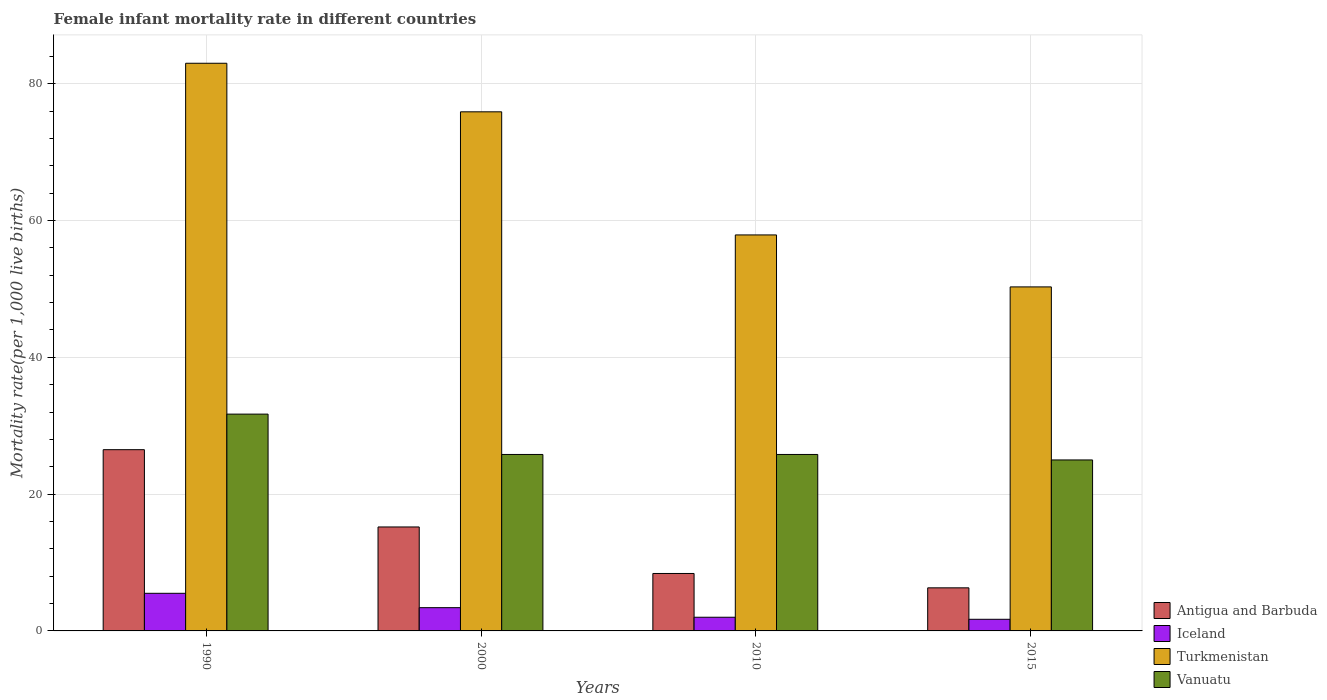Are the number of bars per tick equal to the number of legend labels?
Provide a succinct answer. Yes. How many bars are there on the 3rd tick from the right?
Keep it short and to the point. 4. In how many cases, is the number of bars for a given year not equal to the number of legend labels?
Provide a short and direct response. 0. What is the female infant mortality rate in Vanuatu in 2015?
Make the answer very short. 25. Across all years, what is the maximum female infant mortality rate in Antigua and Barbuda?
Your answer should be compact. 26.5. Across all years, what is the minimum female infant mortality rate in Antigua and Barbuda?
Your answer should be compact. 6.3. In which year was the female infant mortality rate in Iceland minimum?
Keep it short and to the point. 2015. What is the total female infant mortality rate in Antigua and Barbuda in the graph?
Your answer should be compact. 56.4. What is the difference between the female infant mortality rate in Turkmenistan in 1990 and that in 2000?
Offer a terse response. 7.1. What is the difference between the female infant mortality rate in Vanuatu in 2010 and the female infant mortality rate in Turkmenistan in 1990?
Keep it short and to the point. -57.2. What is the average female infant mortality rate in Turkmenistan per year?
Your response must be concise. 66.78. In the year 2010, what is the difference between the female infant mortality rate in Turkmenistan and female infant mortality rate in Antigua and Barbuda?
Your response must be concise. 49.5. In how many years, is the female infant mortality rate in Antigua and Barbuda greater than 40?
Ensure brevity in your answer.  0. What is the ratio of the female infant mortality rate in Antigua and Barbuda in 2000 to that in 2010?
Provide a succinct answer. 1.81. Is the difference between the female infant mortality rate in Turkmenistan in 1990 and 2015 greater than the difference between the female infant mortality rate in Antigua and Barbuda in 1990 and 2015?
Make the answer very short. Yes. What is the difference between the highest and the second highest female infant mortality rate in Iceland?
Provide a succinct answer. 2.1. What is the difference between the highest and the lowest female infant mortality rate in Antigua and Barbuda?
Your answer should be very brief. 20.2. In how many years, is the female infant mortality rate in Turkmenistan greater than the average female infant mortality rate in Turkmenistan taken over all years?
Keep it short and to the point. 2. What does the 1st bar from the left in 1990 represents?
Provide a succinct answer. Antigua and Barbuda. What does the 2nd bar from the right in 2010 represents?
Your answer should be very brief. Turkmenistan. Are all the bars in the graph horizontal?
Ensure brevity in your answer.  No. Does the graph contain any zero values?
Your response must be concise. No. Does the graph contain grids?
Your answer should be compact. Yes. Where does the legend appear in the graph?
Keep it short and to the point. Bottom right. How are the legend labels stacked?
Provide a short and direct response. Vertical. What is the title of the graph?
Keep it short and to the point. Female infant mortality rate in different countries. Does "Finland" appear as one of the legend labels in the graph?
Make the answer very short. No. What is the label or title of the X-axis?
Keep it short and to the point. Years. What is the label or title of the Y-axis?
Ensure brevity in your answer.  Mortality rate(per 1,0 live births). What is the Mortality rate(per 1,000 live births) in Antigua and Barbuda in 1990?
Provide a short and direct response. 26.5. What is the Mortality rate(per 1,000 live births) of Vanuatu in 1990?
Your response must be concise. 31.7. What is the Mortality rate(per 1,000 live births) in Antigua and Barbuda in 2000?
Your answer should be compact. 15.2. What is the Mortality rate(per 1,000 live births) of Iceland in 2000?
Make the answer very short. 3.4. What is the Mortality rate(per 1,000 live births) of Turkmenistan in 2000?
Make the answer very short. 75.9. What is the Mortality rate(per 1,000 live births) of Vanuatu in 2000?
Ensure brevity in your answer.  25.8. What is the Mortality rate(per 1,000 live births) in Turkmenistan in 2010?
Provide a succinct answer. 57.9. What is the Mortality rate(per 1,000 live births) of Vanuatu in 2010?
Provide a succinct answer. 25.8. What is the Mortality rate(per 1,000 live births) in Antigua and Barbuda in 2015?
Provide a succinct answer. 6.3. What is the Mortality rate(per 1,000 live births) of Turkmenistan in 2015?
Offer a terse response. 50.3. Across all years, what is the maximum Mortality rate(per 1,000 live births) in Iceland?
Keep it short and to the point. 5.5. Across all years, what is the maximum Mortality rate(per 1,000 live births) of Vanuatu?
Give a very brief answer. 31.7. Across all years, what is the minimum Mortality rate(per 1,000 live births) in Antigua and Barbuda?
Your answer should be very brief. 6.3. Across all years, what is the minimum Mortality rate(per 1,000 live births) of Turkmenistan?
Provide a short and direct response. 50.3. Across all years, what is the minimum Mortality rate(per 1,000 live births) in Vanuatu?
Your answer should be compact. 25. What is the total Mortality rate(per 1,000 live births) in Antigua and Barbuda in the graph?
Keep it short and to the point. 56.4. What is the total Mortality rate(per 1,000 live births) of Iceland in the graph?
Make the answer very short. 12.6. What is the total Mortality rate(per 1,000 live births) of Turkmenistan in the graph?
Your answer should be very brief. 267.1. What is the total Mortality rate(per 1,000 live births) in Vanuatu in the graph?
Offer a terse response. 108.3. What is the difference between the Mortality rate(per 1,000 live births) of Iceland in 1990 and that in 2010?
Offer a very short reply. 3.5. What is the difference between the Mortality rate(per 1,000 live births) in Turkmenistan in 1990 and that in 2010?
Your answer should be compact. 25.1. What is the difference between the Mortality rate(per 1,000 live births) of Vanuatu in 1990 and that in 2010?
Your answer should be very brief. 5.9. What is the difference between the Mortality rate(per 1,000 live births) in Antigua and Barbuda in 1990 and that in 2015?
Your response must be concise. 20.2. What is the difference between the Mortality rate(per 1,000 live births) of Turkmenistan in 1990 and that in 2015?
Keep it short and to the point. 32.7. What is the difference between the Mortality rate(per 1,000 live births) in Vanuatu in 1990 and that in 2015?
Provide a short and direct response. 6.7. What is the difference between the Mortality rate(per 1,000 live births) in Antigua and Barbuda in 2000 and that in 2010?
Offer a terse response. 6.8. What is the difference between the Mortality rate(per 1,000 live births) in Turkmenistan in 2000 and that in 2010?
Keep it short and to the point. 18. What is the difference between the Mortality rate(per 1,000 live births) of Vanuatu in 2000 and that in 2010?
Ensure brevity in your answer.  0. What is the difference between the Mortality rate(per 1,000 live births) of Antigua and Barbuda in 2000 and that in 2015?
Keep it short and to the point. 8.9. What is the difference between the Mortality rate(per 1,000 live births) in Turkmenistan in 2000 and that in 2015?
Give a very brief answer. 25.6. What is the difference between the Mortality rate(per 1,000 live births) of Turkmenistan in 2010 and that in 2015?
Provide a short and direct response. 7.6. What is the difference between the Mortality rate(per 1,000 live births) of Vanuatu in 2010 and that in 2015?
Give a very brief answer. 0.8. What is the difference between the Mortality rate(per 1,000 live births) of Antigua and Barbuda in 1990 and the Mortality rate(per 1,000 live births) of Iceland in 2000?
Your answer should be very brief. 23.1. What is the difference between the Mortality rate(per 1,000 live births) of Antigua and Barbuda in 1990 and the Mortality rate(per 1,000 live births) of Turkmenistan in 2000?
Give a very brief answer. -49.4. What is the difference between the Mortality rate(per 1,000 live births) in Iceland in 1990 and the Mortality rate(per 1,000 live births) in Turkmenistan in 2000?
Provide a short and direct response. -70.4. What is the difference between the Mortality rate(per 1,000 live births) of Iceland in 1990 and the Mortality rate(per 1,000 live births) of Vanuatu in 2000?
Your answer should be very brief. -20.3. What is the difference between the Mortality rate(per 1,000 live births) of Turkmenistan in 1990 and the Mortality rate(per 1,000 live births) of Vanuatu in 2000?
Your answer should be compact. 57.2. What is the difference between the Mortality rate(per 1,000 live births) in Antigua and Barbuda in 1990 and the Mortality rate(per 1,000 live births) in Turkmenistan in 2010?
Ensure brevity in your answer.  -31.4. What is the difference between the Mortality rate(per 1,000 live births) in Antigua and Barbuda in 1990 and the Mortality rate(per 1,000 live births) in Vanuatu in 2010?
Your response must be concise. 0.7. What is the difference between the Mortality rate(per 1,000 live births) in Iceland in 1990 and the Mortality rate(per 1,000 live births) in Turkmenistan in 2010?
Offer a very short reply. -52.4. What is the difference between the Mortality rate(per 1,000 live births) of Iceland in 1990 and the Mortality rate(per 1,000 live births) of Vanuatu in 2010?
Your answer should be very brief. -20.3. What is the difference between the Mortality rate(per 1,000 live births) in Turkmenistan in 1990 and the Mortality rate(per 1,000 live births) in Vanuatu in 2010?
Your response must be concise. 57.2. What is the difference between the Mortality rate(per 1,000 live births) of Antigua and Barbuda in 1990 and the Mortality rate(per 1,000 live births) of Iceland in 2015?
Your answer should be compact. 24.8. What is the difference between the Mortality rate(per 1,000 live births) in Antigua and Barbuda in 1990 and the Mortality rate(per 1,000 live births) in Turkmenistan in 2015?
Ensure brevity in your answer.  -23.8. What is the difference between the Mortality rate(per 1,000 live births) of Iceland in 1990 and the Mortality rate(per 1,000 live births) of Turkmenistan in 2015?
Your response must be concise. -44.8. What is the difference between the Mortality rate(per 1,000 live births) of Iceland in 1990 and the Mortality rate(per 1,000 live births) of Vanuatu in 2015?
Provide a succinct answer. -19.5. What is the difference between the Mortality rate(per 1,000 live births) in Antigua and Barbuda in 2000 and the Mortality rate(per 1,000 live births) in Iceland in 2010?
Make the answer very short. 13.2. What is the difference between the Mortality rate(per 1,000 live births) of Antigua and Barbuda in 2000 and the Mortality rate(per 1,000 live births) of Turkmenistan in 2010?
Provide a succinct answer. -42.7. What is the difference between the Mortality rate(per 1,000 live births) in Antigua and Barbuda in 2000 and the Mortality rate(per 1,000 live births) in Vanuatu in 2010?
Keep it short and to the point. -10.6. What is the difference between the Mortality rate(per 1,000 live births) of Iceland in 2000 and the Mortality rate(per 1,000 live births) of Turkmenistan in 2010?
Give a very brief answer. -54.5. What is the difference between the Mortality rate(per 1,000 live births) in Iceland in 2000 and the Mortality rate(per 1,000 live births) in Vanuatu in 2010?
Offer a terse response. -22.4. What is the difference between the Mortality rate(per 1,000 live births) in Turkmenistan in 2000 and the Mortality rate(per 1,000 live births) in Vanuatu in 2010?
Your answer should be compact. 50.1. What is the difference between the Mortality rate(per 1,000 live births) in Antigua and Barbuda in 2000 and the Mortality rate(per 1,000 live births) in Turkmenistan in 2015?
Make the answer very short. -35.1. What is the difference between the Mortality rate(per 1,000 live births) in Antigua and Barbuda in 2000 and the Mortality rate(per 1,000 live births) in Vanuatu in 2015?
Offer a terse response. -9.8. What is the difference between the Mortality rate(per 1,000 live births) of Iceland in 2000 and the Mortality rate(per 1,000 live births) of Turkmenistan in 2015?
Offer a terse response. -46.9. What is the difference between the Mortality rate(per 1,000 live births) of Iceland in 2000 and the Mortality rate(per 1,000 live births) of Vanuatu in 2015?
Provide a short and direct response. -21.6. What is the difference between the Mortality rate(per 1,000 live births) of Turkmenistan in 2000 and the Mortality rate(per 1,000 live births) of Vanuatu in 2015?
Ensure brevity in your answer.  50.9. What is the difference between the Mortality rate(per 1,000 live births) of Antigua and Barbuda in 2010 and the Mortality rate(per 1,000 live births) of Iceland in 2015?
Keep it short and to the point. 6.7. What is the difference between the Mortality rate(per 1,000 live births) in Antigua and Barbuda in 2010 and the Mortality rate(per 1,000 live births) in Turkmenistan in 2015?
Provide a succinct answer. -41.9. What is the difference between the Mortality rate(per 1,000 live births) of Antigua and Barbuda in 2010 and the Mortality rate(per 1,000 live births) of Vanuatu in 2015?
Your answer should be very brief. -16.6. What is the difference between the Mortality rate(per 1,000 live births) of Iceland in 2010 and the Mortality rate(per 1,000 live births) of Turkmenistan in 2015?
Your response must be concise. -48.3. What is the difference between the Mortality rate(per 1,000 live births) in Iceland in 2010 and the Mortality rate(per 1,000 live births) in Vanuatu in 2015?
Offer a terse response. -23. What is the difference between the Mortality rate(per 1,000 live births) in Turkmenistan in 2010 and the Mortality rate(per 1,000 live births) in Vanuatu in 2015?
Provide a succinct answer. 32.9. What is the average Mortality rate(per 1,000 live births) of Iceland per year?
Your answer should be very brief. 3.15. What is the average Mortality rate(per 1,000 live births) in Turkmenistan per year?
Offer a terse response. 66.78. What is the average Mortality rate(per 1,000 live births) in Vanuatu per year?
Your answer should be compact. 27.07. In the year 1990, what is the difference between the Mortality rate(per 1,000 live births) in Antigua and Barbuda and Mortality rate(per 1,000 live births) in Iceland?
Your answer should be compact. 21. In the year 1990, what is the difference between the Mortality rate(per 1,000 live births) in Antigua and Barbuda and Mortality rate(per 1,000 live births) in Turkmenistan?
Your answer should be compact. -56.5. In the year 1990, what is the difference between the Mortality rate(per 1,000 live births) of Iceland and Mortality rate(per 1,000 live births) of Turkmenistan?
Provide a short and direct response. -77.5. In the year 1990, what is the difference between the Mortality rate(per 1,000 live births) in Iceland and Mortality rate(per 1,000 live births) in Vanuatu?
Offer a terse response. -26.2. In the year 1990, what is the difference between the Mortality rate(per 1,000 live births) of Turkmenistan and Mortality rate(per 1,000 live births) of Vanuatu?
Give a very brief answer. 51.3. In the year 2000, what is the difference between the Mortality rate(per 1,000 live births) of Antigua and Barbuda and Mortality rate(per 1,000 live births) of Turkmenistan?
Give a very brief answer. -60.7. In the year 2000, what is the difference between the Mortality rate(per 1,000 live births) in Iceland and Mortality rate(per 1,000 live births) in Turkmenistan?
Provide a succinct answer. -72.5. In the year 2000, what is the difference between the Mortality rate(per 1,000 live births) of Iceland and Mortality rate(per 1,000 live births) of Vanuatu?
Offer a very short reply. -22.4. In the year 2000, what is the difference between the Mortality rate(per 1,000 live births) of Turkmenistan and Mortality rate(per 1,000 live births) of Vanuatu?
Your answer should be very brief. 50.1. In the year 2010, what is the difference between the Mortality rate(per 1,000 live births) in Antigua and Barbuda and Mortality rate(per 1,000 live births) in Iceland?
Provide a succinct answer. 6.4. In the year 2010, what is the difference between the Mortality rate(per 1,000 live births) in Antigua and Barbuda and Mortality rate(per 1,000 live births) in Turkmenistan?
Offer a very short reply. -49.5. In the year 2010, what is the difference between the Mortality rate(per 1,000 live births) of Antigua and Barbuda and Mortality rate(per 1,000 live births) of Vanuatu?
Your answer should be compact. -17.4. In the year 2010, what is the difference between the Mortality rate(per 1,000 live births) in Iceland and Mortality rate(per 1,000 live births) in Turkmenistan?
Make the answer very short. -55.9. In the year 2010, what is the difference between the Mortality rate(per 1,000 live births) in Iceland and Mortality rate(per 1,000 live births) in Vanuatu?
Keep it short and to the point. -23.8. In the year 2010, what is the difference between the Mortality rate(per 1,000 live births) of Turkmenistan and Mortality rate(per 1,000 live births) of Vanuatu?
Give a very brief answer. 32.1. In the year 2015, what is the difference between the Mortality rate(per 1,000 live births) in Antigua and Barbuda and Mortality rate(per 1,000 live births) in Turkmenistan?
Your answer should be compact. -44. In the year 2015, what is the difference between the Mortality rate(per 1,000 live births) of Antigua and Barbuda and Mortality rate(per 1,000 live births) of Vanuatu?
Your answer should be very brief. -18.7. In the year 2015, what is the difference between the Mortality rate(per 1,000 live births) of Iceland and Mortality rate(per 1,000 live births) of Turkmenistan?
Provide a succinct answer. -48.6. In the year 2015, what is the difference between the Mortality rate(per 1,000 live births) in Iceland and Mortality rate(per 1,000 live births) in Vanuatu?
Your response must be concise. -23.3. In the year 2015, what is the difference between the Mortality rate(per 1,000 live births) of Turkmenistan and Mortality rate(per 1,000 live births) of Vanuatu?
Offer a very short reply. 25.3. What is the ratio of the Mortality rate(per 1,000 live births) of Antigua and Barbuda in 1990 to that in 2000?
Offer a very short reply. 1.74. What is the ratio of the Mortality rate(per 1,000 live births) in Iceland in 1990 to that in 2000?
Give a very brief answer. 1.62. What is the ratio of the Mortality rate(per 1,000 live births) in Turkmenistan in 1990 to that in 2000?
Your answer should be compact. 1.09. What is the ratio of the Mortality rate(per 1,000 live births) in Vanuatu in 1990 to that in 2000?
Provide a short and direct response. 1.23. What is the ratio of the Mortality rate(per 1,000 live births) in Antigua and Barbuda in 1990 to that in 2010?
Your answer should be very brief. 3.15. What is the ratio of the Mortality rate(per 1,000 live births) of Iceland in 1990 to that in 2010?
Provide a short and direct response. 2.75. What is the ratio of the Mortality rate(per 1,000 live births) of Turkmenistan in 1990 to that in 2010?
Provide a succinct answer. 1.43. What is the ratio of the Mortality rate(per 1,000 live births) of Vanuatu in 1990 to that in 2010?
Give a very brief answer. 1.23. What is the ratio of the Mortality rate(per 1,000 live births) in Antigua and Barbuda in 1990 to that in 2015?
Ensure brevity in your answer.  4.21. What is the ratio of the Mortality rate(per 1,000 live births) of Iceland in 1990 to that in 2015?
Ensure brevity in your answer.  3.24. What is the ratio of the Mortality rate(per 1,000 live births) in Turkmenistan in 1990 to that in 2015?
Keep it short and to the point. 1.65. What is the ratio of the Mortality rate(per 1,000 live births) of Vanuatu in 1990 to that in 2015?
Provide a short and direct response. 1.27. What is the ratio of the Mortality rate(per 1,000 live births) of Antigua and Barbuda in 2000 to that in 2010?
Your answer should be compact. 1.81. What is the ratio of the Mortality rate(per 1,000 live births) of Turkmenistan in 2000 to that in 2010?
Your response must be concise. 1.31. What is the ratio of the Mortality rate(per 1,000 live births) in Antigua and Barbuda in 2000 to that in 2015?
Keep it short and to the point. 2.41. What is the ratio of the Mortality rate(per 1,000 live births) of Turkmenistan in 2000 to that in 2015?
Provide a succinct answer. 1.51. What is the ratio of the Mortality rate(per 1,000 live births) in Vanuatu in 2000 to that in 2015?
Your response must be concise. 1.03. What is the ratio of the Mortality rate(per 1,000 live births) in Antigua and Barbuda in 2010 to that in 2015?
Ensure brevity in your answer.  1.33. What is the ratio of the Mortality rate(per 1,000 live births) in Iceland in 2010 to that in 2015?
Your answer should be compact. 1.18. What is the ratio of the Mortality rate(per 1,000 live births) of Turkmenistan in 2010 to that in 2015?
Your response must be concise. 1.15. What is the ratio of the Mortality rate(per 1,000 live births) of Vanuatu in 2010 to that in 2015?
Offer a very short reply. 1.03. What is the difference between the highest and the second highest Mortality rate(per 1,000 live births) in Antigua and Barbuda?
Give a very brief answer. 11.3. What is the difference between the highest and the second highest Mortality rate(per 1,000 live births) of Turkmenistan?
Ensure brevity in your answer.  7.1. What is the difference between the highest and the lowest Mortality rate(per 1,000 live births) of Antigua and Barbuda?
Your response must be concise. 20.2. What is the difference between the highest and the lowest Mortality rate(per 1,000 live births) of Iceland?
Ensure brevity in your answer.  3.8. What is the difference between the highest and the lowest Mortality rate(per 1,000 live births) of Turkmenistan?
Ensure brevity in your answer.  32.7. What is the difference between the highest and the lowest Mortality rate(per 1,000 live births) of Vanuatu?
Offer a very short reply. 6.7. 